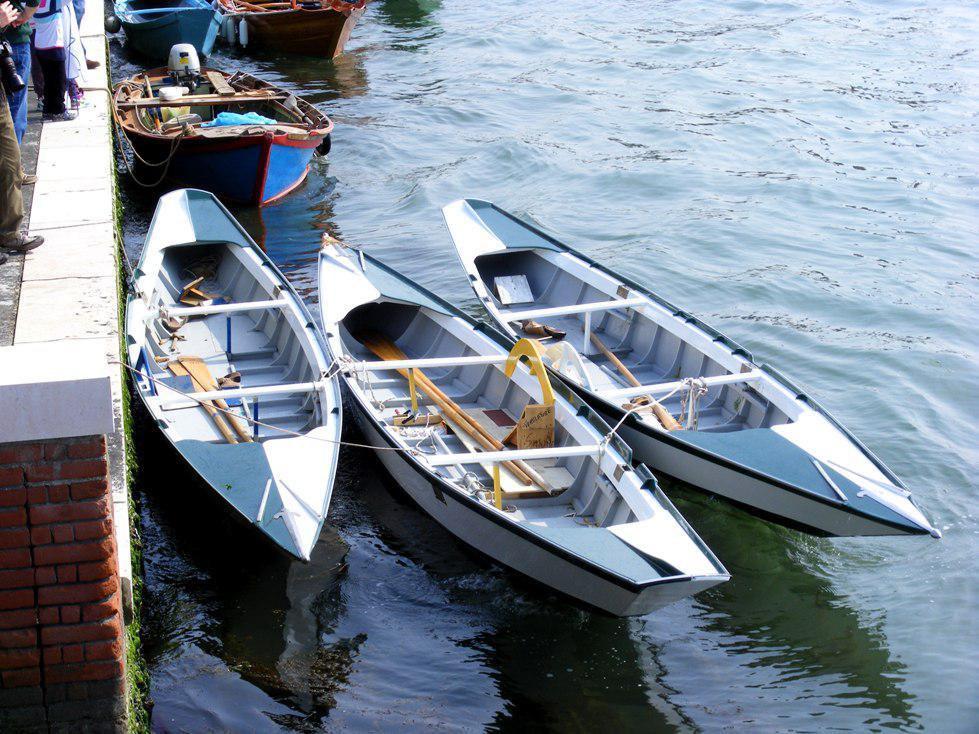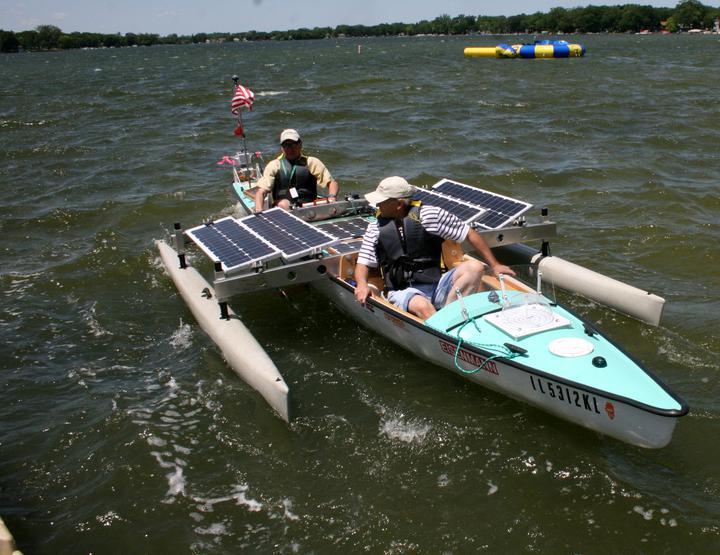The first image is the image on the left, the second image is the image on the right. Assess this claim about the two images: "Each image shows in the foreground a boat containing gear pulled up to the water's edge so it is partly on ground.". Correct or not? Answer yes or no. No. The first image is the image on the left, the second image is the image on the right. Evaluate the accuracy of this statement regarding the images: "At least one person is sitting in a canoe in the image on the right.". Is it true? Answer yes or no. Yes. 